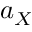Convert formula to latex. <formula><loc_0><loc_0><loc_500><loc_500>a _ { X }</formula> 